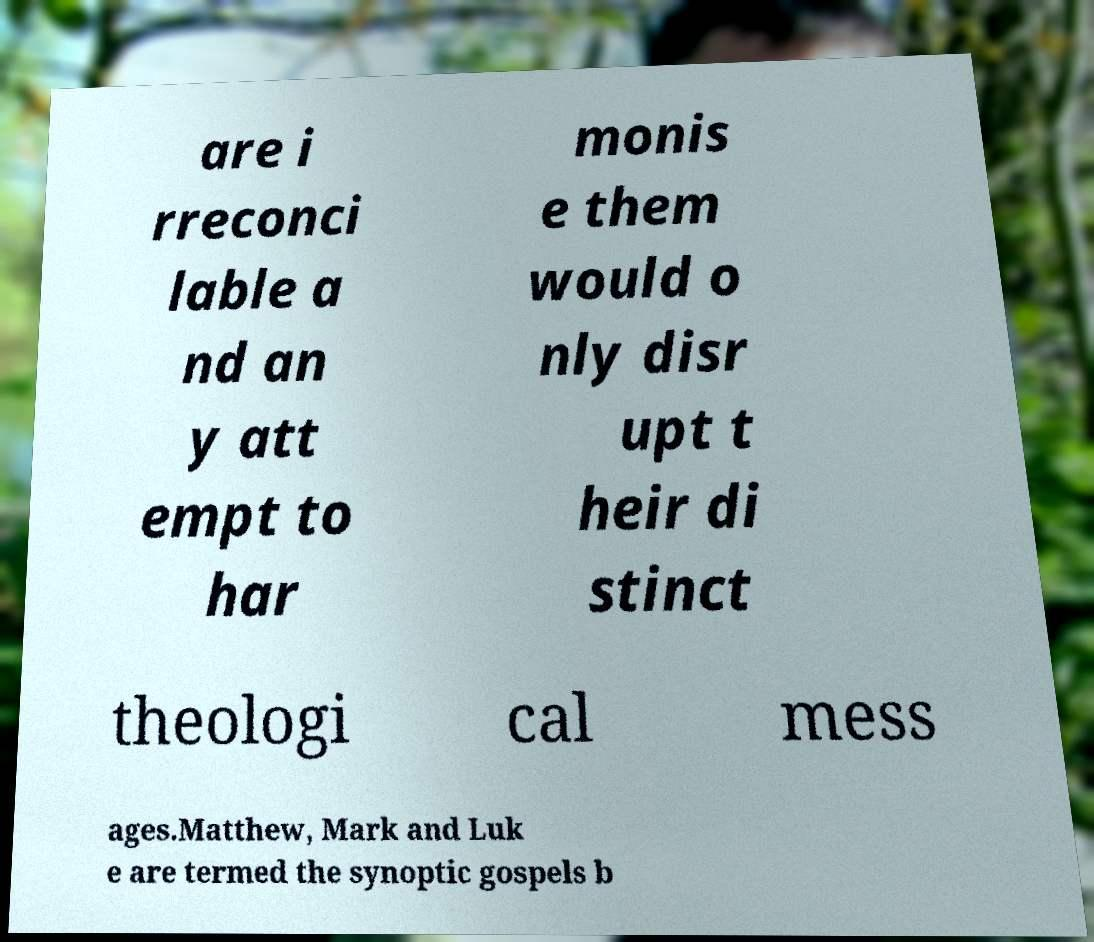Please identify and transcribe the text found in this image. are i rreconci lable a nd an y att empt to har monis e them would o nly disr upt t heir di stinct theologi cal mess ages.Matthew, Mark and Luk e are termed the synoptic gospels b 